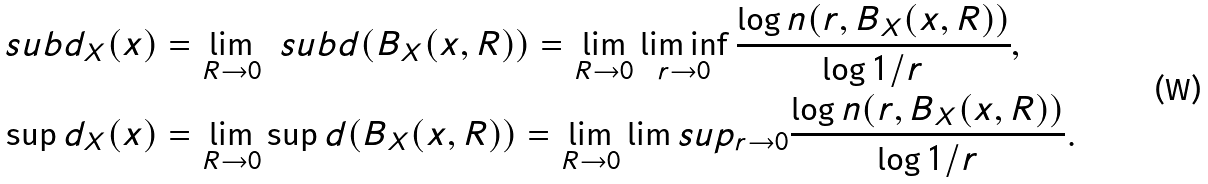<formula> <loc_0><loc_0><loc_500><loc_500>\ s u b d _ { X } ( x ) & = \lim _ { R \to 0 } \ s u b d ( B _ { X } ( x , R ) ) = \lim _ { R \to 0 } \liminf _ { r \to 0 } \frac { \log n ( r , B _ { X } ( x , R ) ) } { \log 1 / r } , \\ \sup d _ { X } ( x ) & = \lim _ { R \to 0 } \sup d ( B _ { X } ( x , R ) ) = \lim _ { R \to 0 } \lim s u p _ { r \to 0 } \frac { \log n ( r , B _ { X } ( x , R ) ) } { \log 1 / r } .</formula> 